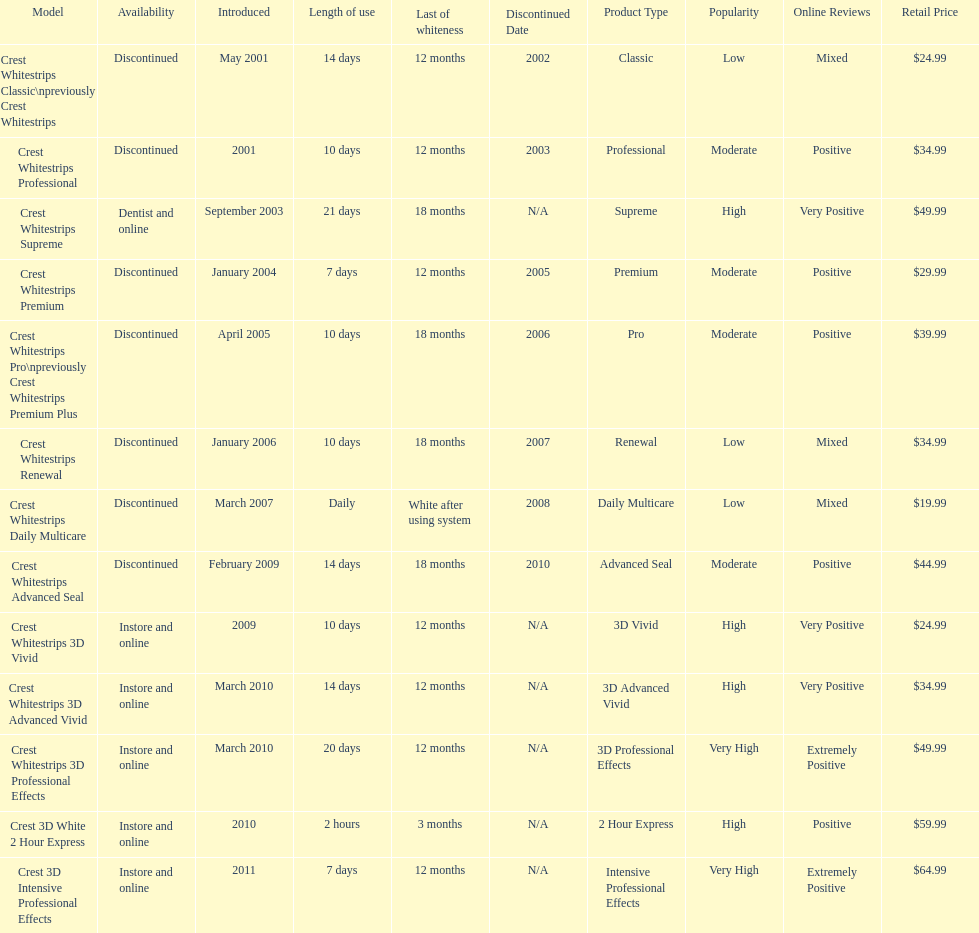How many models require less than a week of use? 2. 